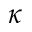<formula> <loc_0><loc_0><loc_500><loc_500>\kappa</formula> 